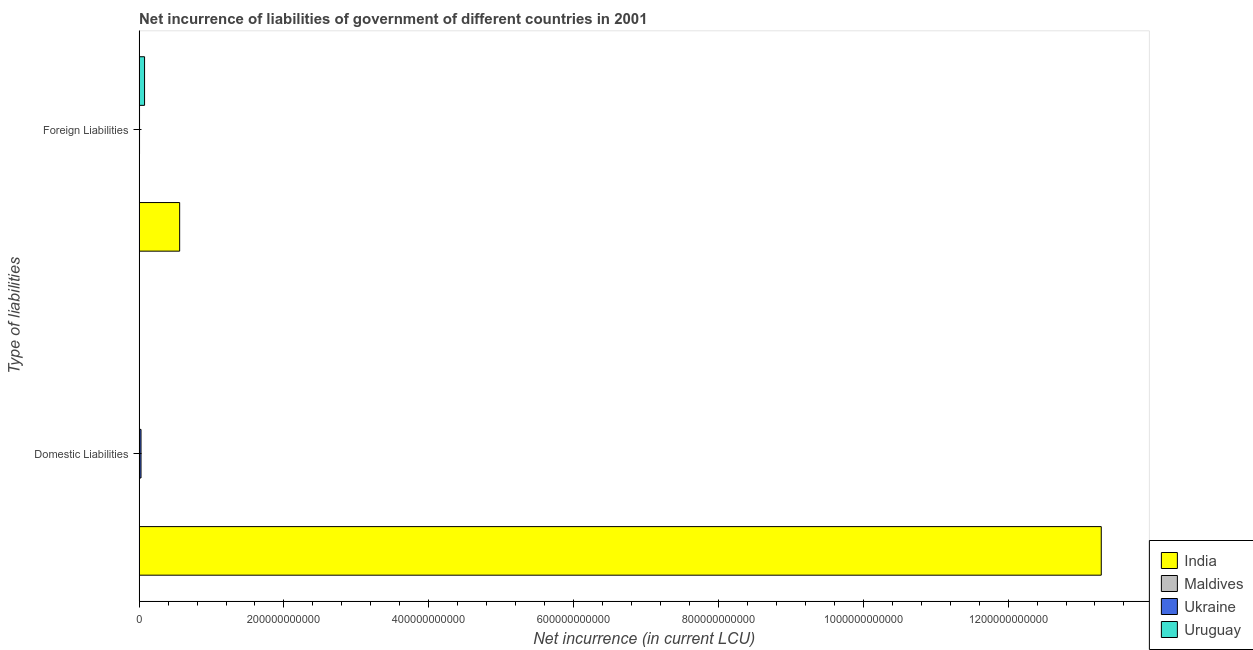How many different coloured bars are there?
Make the answer very short. 4. How many groups of bars are there?
Offer a terse response. 2. Are the number of bars on each tick of the Y-axis equal?
Provide a succinct answer. No. What is the label of the 1st group of bars from the top?
Keep it short and to the point. Foreign Liabilities. What is the net incurrence of foreign liabilities in Uruguay?
Your answer should be very brief. 7.54e+09. Across all countries, what is the maximum net incurrence of foreign liabilities?
Offer a very short reply. 5.60e+1. In which country was the net incurrence of domestic liabilities maximum?
Give a very brief answer. India. What is the total net incurrence of domestic liabilities in the graph?
Offer a very short reply. 1.33e+12. What is the difference between the net incurrence of foreign liabilities in Maldives and that in India?
Give a very brief answer. -5.59e+1. What is the difference between the net incurrence of domestic liabilities in India and the net incurrence of foreign liabilities in Maldives?
Provide a short and direct response. 1.33e+12. What is the average net incurrence of domestic liabilities per country?
Make the answer very short. 3.33e+11. What is the difference between the net incurrence of domestic liabilities and net incurrence of foreign liabilities in Ukraine?
Your response must be concise. 2.04e+09. In how many countries, is the net incurrence of foreign liabilities greater than 840000000000 LCU?
Offer a terse response. 0. What is the ratio of the net incurrence of foreign liabilities in India to that in Ukraine?
Offer a very short reply. 94.6. In how many countries, is the net incurrence of foreign liabilities greater than the average net incurrence of foreign liabilities taken over all countries?
Your response must be concise. 1. What is the difference between two consecutive major ticks on the X-axis?
Give a very brief answer. 2.00e+11. Does the graph contain grids?
Provide a short and direct response. No. Where does the legend appear in the graph?
Ensure brevity in your answer.  Bottom right. What is the title of the graph?
Give a very brief answer. Net incurrence of liabilities of government of different countries in 2001. Does "Cyprus" appear as one of the legend labels in the graph?
Make the answer very short. No. What is the label or title of the X-axis?
Offer a very short reply. Net incurrence (in current LCU). What is the label or title of the Y-axis?
Your answer should be compact. Type of liabilities. What is the Net incurrence (in current LCU) of India in Domestic Liabilities?
Your response must be concise. 1.33e+12. What is the Net incurrence (in current LCU) of Maldives in Domestic Liabilities?
Offer a very short reply. 2.45e+08. What is the Net incurrence (in current LCU) in Ukraine in Domestic Liabilities?
Provide a short and direct response. 2.63e+09. What is the Net incurrence (in current LCU) of Uruguay in Domestic Liabilities?
Provide a succinct answer. 0. What is the Net incurrence (in current LCU) of India in Foreign Liabilities?
Your response must be concise. 5.60e+1. What is the Net incurrence (in current LCU) of Maldives in Foreign Liabilities?
Provide a succinct answer. 1.46e+08. What is the Net incurrence (in current LCU) in Ukraine in Foreign Liabilities?
Your answer should be very brief. 5.92e+08. What is the Net incurrence (in current LCU) in Uruguay in Foreign Liabilities?
Your answer should be very brief. 7.54e+09. Across all Type of liabilities, what is the maximum Net incurrence (in current LCU) in India?
Offer a terse response. 1.33e+12. Across all Type of liabilities, what is the maximum Net incurrence (in current LCU) of Maldives?
Provide a succinct answer. 2.45e+08. Across all Type of liabilities, what is the maximum Net incurrence (in current LCU) in Ukraine?
Your answer should be very brief. 2.63e+09. Across all Type of liabilities, what is the maximum Net incurrence (in current LCU) of Uruguay?
Your answer should be compact. 7.54e+09. Across all Type of liabilities, what is the minimum Net incurrence (in current LCU) in India?
Your answer should be compact. 5.60e+1. Across all Type of liabilities, what is the minimum Net incurrence (in current LCU) in Maldives?
Make the answer very short. 1.46e+08. Across all Type of liabilities, what is the minimum Net incurrence (in current LCU) of Ukraine?
Ensure brevity in your answer.  5.92e+08. Across all Type of liabilities, what is the minimum Net incurrence (in current LCU) of Uruguay?
Offer a very short reply. 0. What is the total Net incurrence (in current LCU) in India in the graph?
Make the answer very short. 1.38e+12. What is the total Net incurrence (in current LCU) of Maldives in the graph?
Your response must be concise. 3.91e+08. What is the total Net incurrence (in current LCU) in Ukraine in the graph?
Offer a very short reply. 3.22e+09. What is the total Net incurrence (in current LCU) in Uruguay in the graph?
Provide a succinct answer. 7.54e+09. What is the difference between the Net incurrence (in current LCU) in India in Domestic Liabilities and that in Foreign Liabilities?
Your response must be concise. 1.27e+12. What is the difference between the Net incurrence (in current LCU) of Maldives in Domestic Liabilities and that in Foreign Liabilities?
Keep it short and to the point. 9.91e+07. What is the difference between the Net incurrence (in current LCU) of Ukraine in Domestic Liabilities and that in Foreign Liabilities?
Offer a terse response. 2.04e+09. What is the difference between the Net incurrence (in current LCU) in India in Domestic Liabilities and the Net incurrence (in current LCU) in Maldives in Foreign Liabilities?
Make the answer very short. 1.33e+12. What is the difference between the Net incurrence (in current LCU) in India in Domestic Liabilities and the Net incurrence (in current LCU) in Ukraine in Foreign Liabilities?
Give a very brief answer. 1.33e+12. What is the difference between the Net incurrence (in current LCU) in India in Domestic Liabilities and the Net incurrence (in current LCU) in Uruguay in Foreign Liabilities?
Your response must be concise. 1.32e+12. What is the difference between the Net incurrence (in current LCU) in Maldives in Domestic Liabilities and the Net incurrence (in current LCU) in Ukraine in Foreign Liabilities?
Give a very brief answer. -3.47e+08. What is the difference between the Net incurrence (in current LCU) of Maldives in Domestic Liabilities and the Net incurrence (in current LCU) of Uruguay in Foreign Liabilities?
Offer a terse response. -7.30e+09. What is the difference between the Net incurrence (in current LCU) of Ukraine in Domestic Liabilities and the Net incurrence (in current LCU) of Uruguay in Foreign Liabilities?
Give a very brief answer. -4.91e+09. What is the average Net incurrence (in current LCU) of India per Type of liabilities?
Make the answer very short. 6.92e+11. What is the average Net incurrence (in current LCU) of Maldives per Type of liabilities?
Your answer should be very brief. 1.95e+08. What is the average Net incurrence (in current LCU) in Ukraine per Type of liabilities?
Provide a short and direct response. 1.61e+09. What is the average Net incurrence (in current LCU) of Uruguay per Type of liabilities?
Provide a succinct answer. 3.77e+09. What is the difference between the Net incurrence (in current LCU) of India and Net incurrence (in current LCU) of Maldives in Domestic Liabilities?
Provide a short and direct response. 1.33e+12. What is the difference between the Net incurrence (in current LCU) in India and Net incurrence (in current LCU) in Ukraine in Domestic Liabilities?
Provide a short and direct response. 1.33e+12. What is the difference between the Net incurrence (in current LCU) in Maldives and Net incurrence (in current LCU) in Ukraine in Domestic Liabilities?
Give a very brief answer. -2.39e+09. What is the difference between the Net incurrence (in current LCU) in India and Net incurrence (in current LCU) in Maldives in Foreign Liabilities?
Keep it short and to the point. 5.59e+1. What is the difference between the Net incurrence (in current LCU) of India and Net incurrence (in current LCU) of Ukraine in Foreign Liabilities?
Ensure brevity in your answer.  5.54e+1. What is the difference between the Net incurrence (in current LCU) of India and Net incurrence (in current LCU) of Uruguay in Foreign Liabilities?
Make the answer very short. 4.85e+1. What is the difference between the Net incurrence (in current LCU) in Maldives and Net incurrence (in current LCU) in Ukraine in Foreign Liabilities?
Offer a terse response. -4.46e+08. What is the difference between the Net incurrence (in current LCU) of Maldives and Net incurrence (in current LCU) of Uruguay in Foreign Liabilities?
Offer a terse response. -7.40e+09. What is the difference between the Net incurrence (in current LCU) of Ukraine and Net incurrence (in current LCU) of Uruguay in Foreign Liabilities?
Give a very brief answer. -6.95e+09. What is the ratio of the Net incurrence (in current LCU) of India in Domestic Liabilities to that in Foreign Liabilities?
Make the answer very short. 23.72. What is the ratio of the Net incurrence (in current LCU) of Maldives in Domestic Liabilities to that in Foreign Liabilities?
Your answer should be very brief. 1.68. What is the ratio of the Net incurrence (in current LCU) of Ukraine in Domestic Liabilities to that in Foreign Liabilities?
Provide a succinct answer. 4.45. What is the difference between the highest and the second highest Net incurrence (in current LCU) of India?
Offer a very short reply. 1.27e+12. What is the difference between the highest and the second highest Net incurrence (in current LCU) of Maldives?
Give a very brief answer. 9.91e+07. What is the difference between the highest and the second highest Net incurrence (in current LCU) of Ukraine?
Your response must be concise. 2.04e+09. What is the difference between the highest and the lowest Net incurrence (in current LCU) of India?
Your response must be concise. 1.27e+12. What is the difference between the highest and the lowest Net incurrence (in current LCU) of Maldives?
Your answer should be very brief. 9.91e+07. What is the difference between the highest and the lowest Net incurrence (in current LCU) of Ukraine?
Give a very brief answer. 2.04e+09. What is the difference between the highest and the lowest Net incurrence (in current LCU) of Uruguay?
Provide a short and direct response. 7.54e+09. 